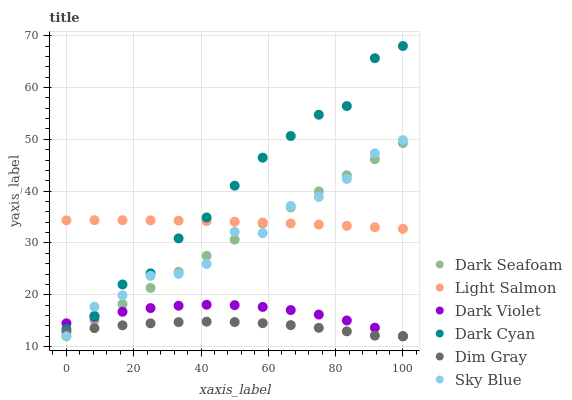Does Dim Gray have the minimum area under the curve?
Answer yes or no. Yes. Does Dark Cyan have the maximum area under the curve?
Answer yes or no. Yes. Does Dark Violet have the minimum area under the curve?
Answer yes or no. No. Does Dark Violet have the maximum area under the curve?
Answer yes or no. No. Is Dark Seafoam the smoothest?
Answer yes or no. Yes. Is Dark Cyan the roughest?
Answer yes or no. Yes. Is Dim Gray the smoothest?
Answer yes or no. No. Is Dim Gray the roughest?
Answer yes or no. No. Does Dim Gray have the lowest value?
Answer yes or no. Yes. Does Dark Cyan have the lowest value?
Answer yes or no. No. Does Dark Cyan have the highest value?
Answer yes or no. Yes. Does Dark Violet have the highest value?
Answer yes or no. No. Is Dark Seafoam less than Dark Cyan?
Answer yes or no. Yes. Is Light Salmon greater than Dim Gray?
Answer yes or no. Yes. Does Dark Seafoam intersect Sky Blue?
Answer yes or no. Yes. Is Dark Seafoam less than Sky Blue?
Answer yes or no. No. Is Dark Seafoam greater than Sky Blue?
Answer yes or no. No. Does Dark Seafoam intersect Dark Cyan?
Answer yes or no. No. 